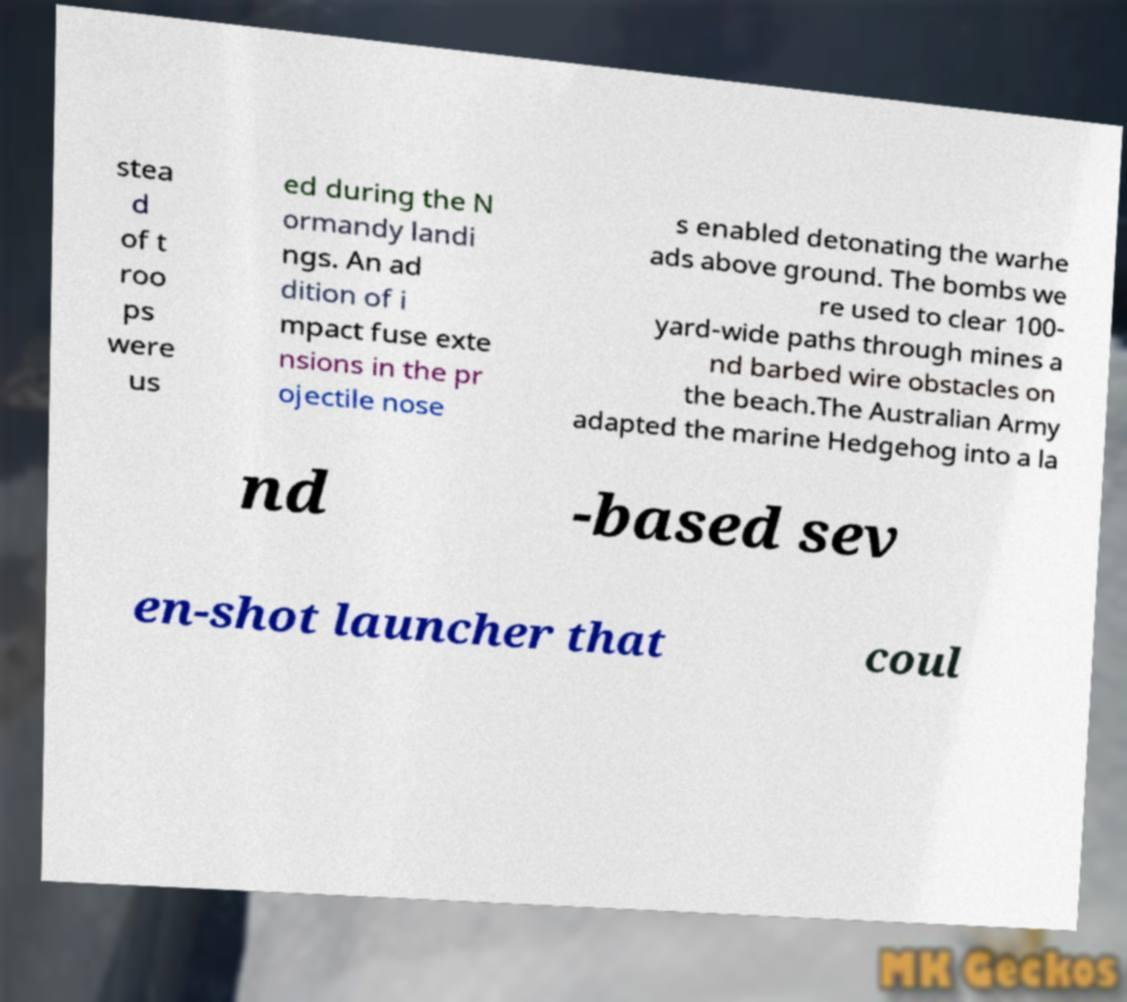Could you assist in decoding the text presented in this image and type it out clearly? stea d of t roo ps were us ed during the N ormandy landi ngs. An ad dition of i mpact fuse exte nsions in the pr ojectile nose s enabled detonating the warhe ads above ground. The bombs we re used to clear 100- yard-wide paths through mines a nd barbed wire obstacles on the beach.The Australian Army adapted the marine Hedgehog into a la nd -based sev en-shot launcher that coul 